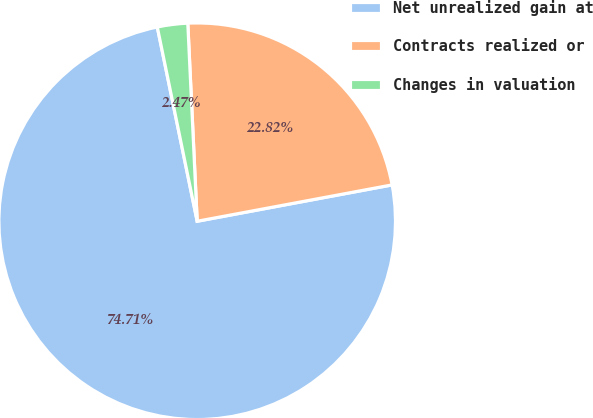Convert chart. <chart><loc_0><loc_0><loc_500><loc_500><pie_chart><fcel>Net unrealized gain at<fcel>Contracts realized or<fcel>Changes in valuation<nl><fcel>74.71%<fcel>22.82%<fcel>2.47%<nl></chart> 